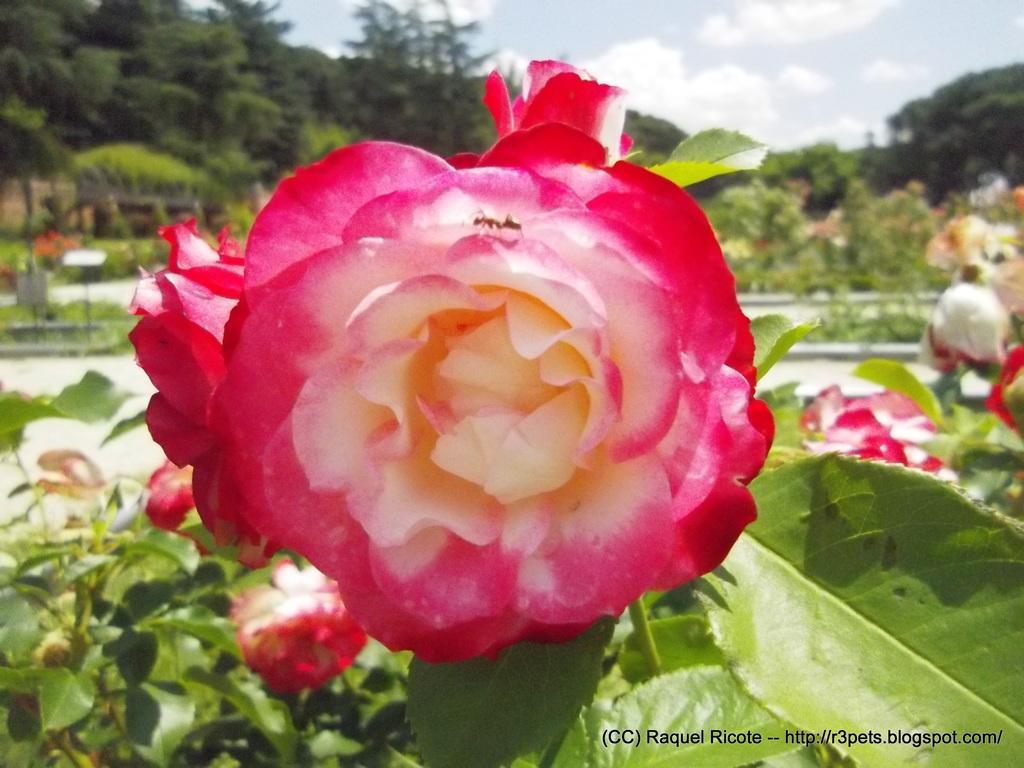Describe this image in one or two sentences. In the image there is a pink and white color flower with leaves. Behind them there are many plants with flowers and leaves. In the background there are trees. At the top of the image there is a sky with clouds. 